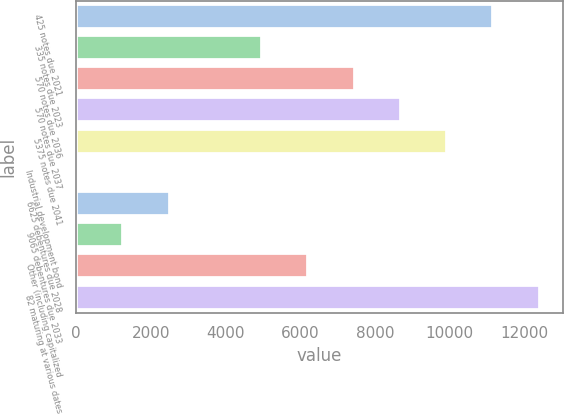Convert chart to OTSL. <chart><loc_0><loc_0><loc_500><loc_500><bar_chart><fcel>425 notes due 2021<fcel>335 notes due 2023<fcel>570 notes due 2036<fcel>570 notes due 2037<fcel>5375 notes due 2041<fcel>Industrial development bond<fcel>6625 debentures due 2028<fcel>9065 debentures due 2033<fcel>Other (including capitalized<fcel>82 maturing at various dates<nl><fcel>11171.1<fcel>4981.6<fcel>7457.4<fcel>8695.3<fcel>9933.2<fcel>30<fcel>2505.8<fcel>1267.9<fcel>6219.5<fcel>12409<nl></chart> 